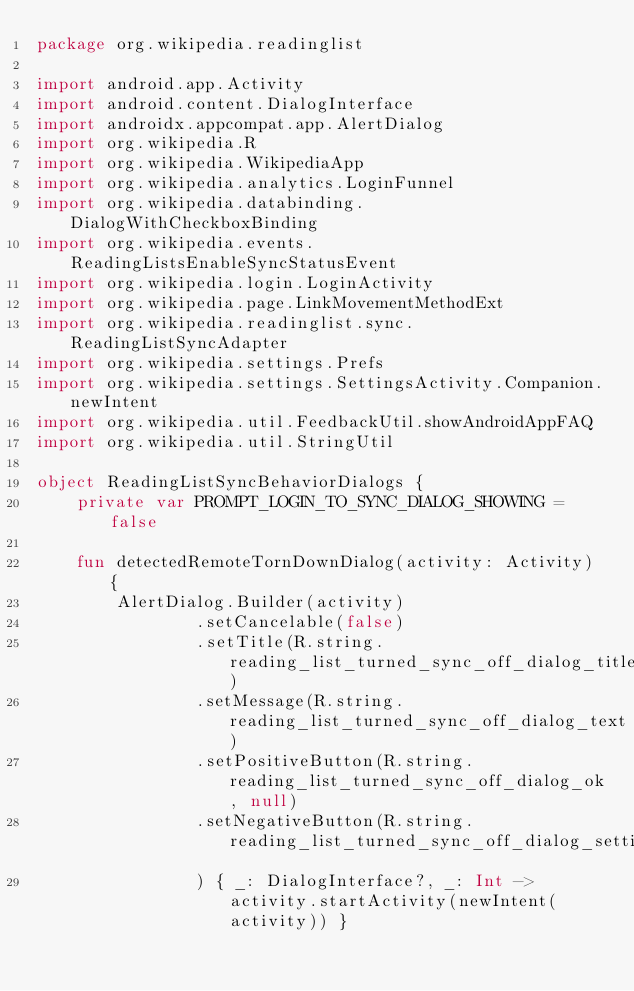<code> <loc_0><loc_0><loc_500><loc_500><_Kotlin_>package org.wikipedia.readinglist

import android.app.Activity
import android.content.DialogInterface
import androidx.appcompat.app.AlertDialog
import org.wikipedia.R
import org.wikipedia.WikipediaApp
import org.wikipedia.analytics.LoginFunnel
import org.wikipedia.databinding.DialogWithCheckboxBinding
import org.wikipedia.events.ReadingListsEnableSyncStatusEvent
import org.wikipedia.login.LoginActivity
import org.wikipedia.page.LinkMovementMethodExt
import org.wikipedia.readinglist.sync.ReadingListSyncAdapter
import org.wikipedia.settings.Prefs
import org.wikipedia.settings.SettingsActivity.Companion.newIntent
import org.wikipedia.util.FeedbackUtil.showAndroidAppFAQ
import org.wikipedia.util.StringUtil

object ReadingListSyncBehaviorDialogs {
    private var PROMPT_LOGIN_TO_SYNC_DIALOG_SHOWING = false

    fun detectedRemoteTornDownDialog(activity: Activity) {
        AlertDialog.Builder(activity)
                .setCancelable(false)
                .setTitle(R.string.reading_list_turned_sync_off_dialog_title)
                .setMessage(R.string.reading_list_turned_sync_off_dialog_text)
                .setPositiveButton(R.string.reading_list_turned_sync_off_dialog_ok, null)
                .setNegativeButton(R.string.reading_list_turned_sync_off_dialog_settings
                ) { _: DialogInterface?, _: Int -> activity.startActivity(newIntent(activity)) }</code> 